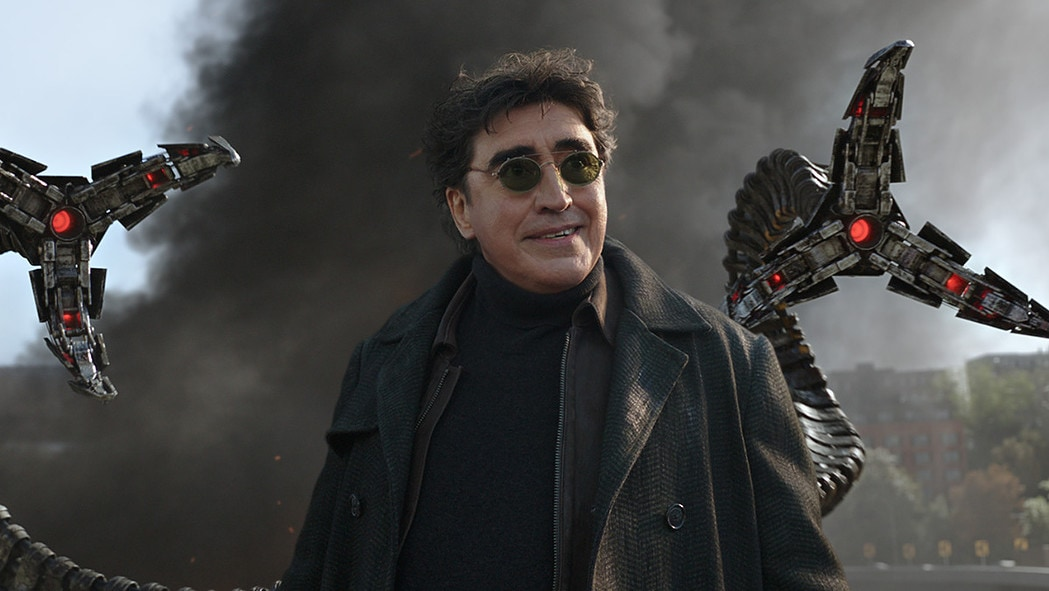What can you tell me about the character in this image? The character in this image is Doctor Octopus, a well-known villain from the Spider-Man series. He is characterized by his four mechanical tentacles, which he uses for mobility, combat, and manipulation of objects. His real name is Dr. Otto Octavius, and he was originally a respected scientist who, after an experiment went wrong, became the infamous Doctor Octopus. What are some key traits of Doctor Octopus? Doctor Octopus is known for his genius-level intellect and his ability to control his mechanical tentacles with great precision. He has a strong will and often possesses a ruthless and ambitious personality, driven by both personal vendettas and a desire for power. His background as a scientist makes him a formidable opponent, as he combines his knowledge of advanced technology with his relentless ambition. Can you describe a memorable scene involving Doctor Octopus? One of the most memorable scenes involving Doctor Octopus is from the movie Spider-Man 2 (2004). In this scene, Doctor Octopus orchestrates an intense battle on a speeding train. Using his mechanical tentacles, he causes immense chaos by destroying parts of the train and throwing passengers into peril, forcing Spider-Man to use all his strength and agility to save the passengers and stop the train from derailing. This scene highlights Doctor Octopus's sheer power and the dramatic tension between him and Spider-Man. 